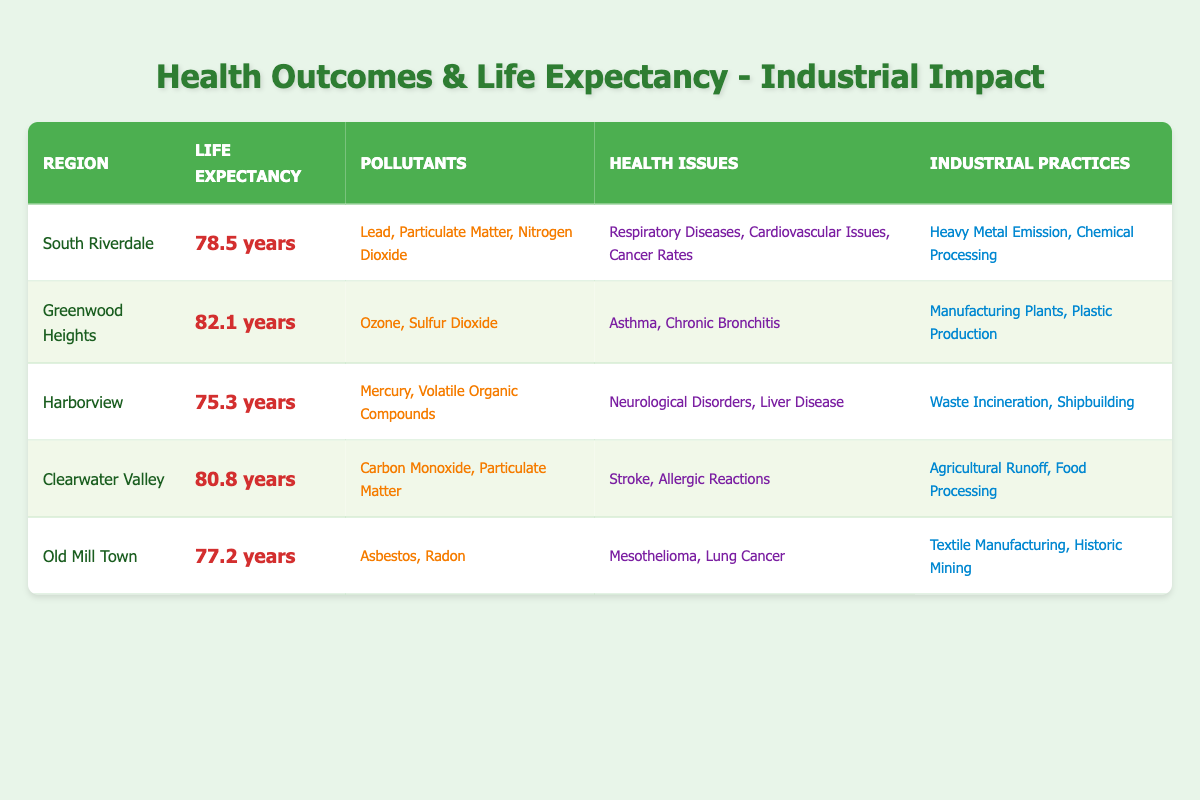What is the average life expectancy in Greenwood Heights? The table shows Greenwood Heights has an average life expectancy of 82.1 years, which is a direct retrieval from the corresponding row in the table.
Answer: 82.1 years How many pollutants are listed for Harborview? In the table, the pollutants listed for Harborview are Mercury and Volatile Organic Compounds, amounting to a total of 2 pollutants.
Answer: 2 pollutants Which region has the highest life expectancy? By comparing the life expectancy values in the table, Greenwood Heights (82.1 years) has the highest life expectancy among all regions.
Answer: Greenwood Heights Is the average life expectancy in Clearwater Valley above or below 80 years? The table states Clearwater Valley has an average life expectancy of 80.8 years, which is above 80.
Answer: Above What is the difference in average life expectancy between South Riverdale and Old Mill Town? South Riverdale has an average life expectancy of 78.5 years, and Old Mill Town has 77.2 years. The difference is 78.5 - 77.2 = 1.3 years.
Answer: 1.3 years Are there more health issues listed for South Riverdale than for Greenwood Heights? South Riverdale lists three health issues: Respiratory Diseases, Cardiovascular Issues, and Cancer Rates, while Greenwood Heights has two: Asthma and Chronic Bronchitis. Therefore, South Riverdale lists more health issues.
Answer: Yes What is the average life expectancy of regions dealing with heavy metal emissions? The regions dealing with heavy metal emissions are South Riverdale (78.5 years) and Harborview (75.3 years). The average is (78.5 + 75.3) / 2 = 76.9 years.
Answer: 76.9 years Which pollutants are common in areas with lower average life expectancy? Both South Riverdale and Harborview, which have lower life expectancies (78.5 and 75.3 years), have pollutants that include Lead and Mercury. Thus, these specific pollutants are common.
Answer: Lead and Mercury Is there a region with no respiratory health issues mentioned? Yes, Greenwood Heights lists only Asthma and Chronic Bronchitis as health issues, which are both respiratory, whereas Harborview has neurological and liver issues. Therefore, resulting in the answer being yes.
Answer: Yes 